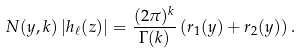Convert formula to latex. <formula><loc_0><loc_0><loc_500><loc_500>N ( y , k ) \left | h _ { \ell } ( z ) \right | = \frac { ( 2 \pi ) ^ { k } } { \Gamma ( k ) } \left ( r _ { 1 } ( y ) + r _ { 2 } ( y ) \right ) .</formula> 